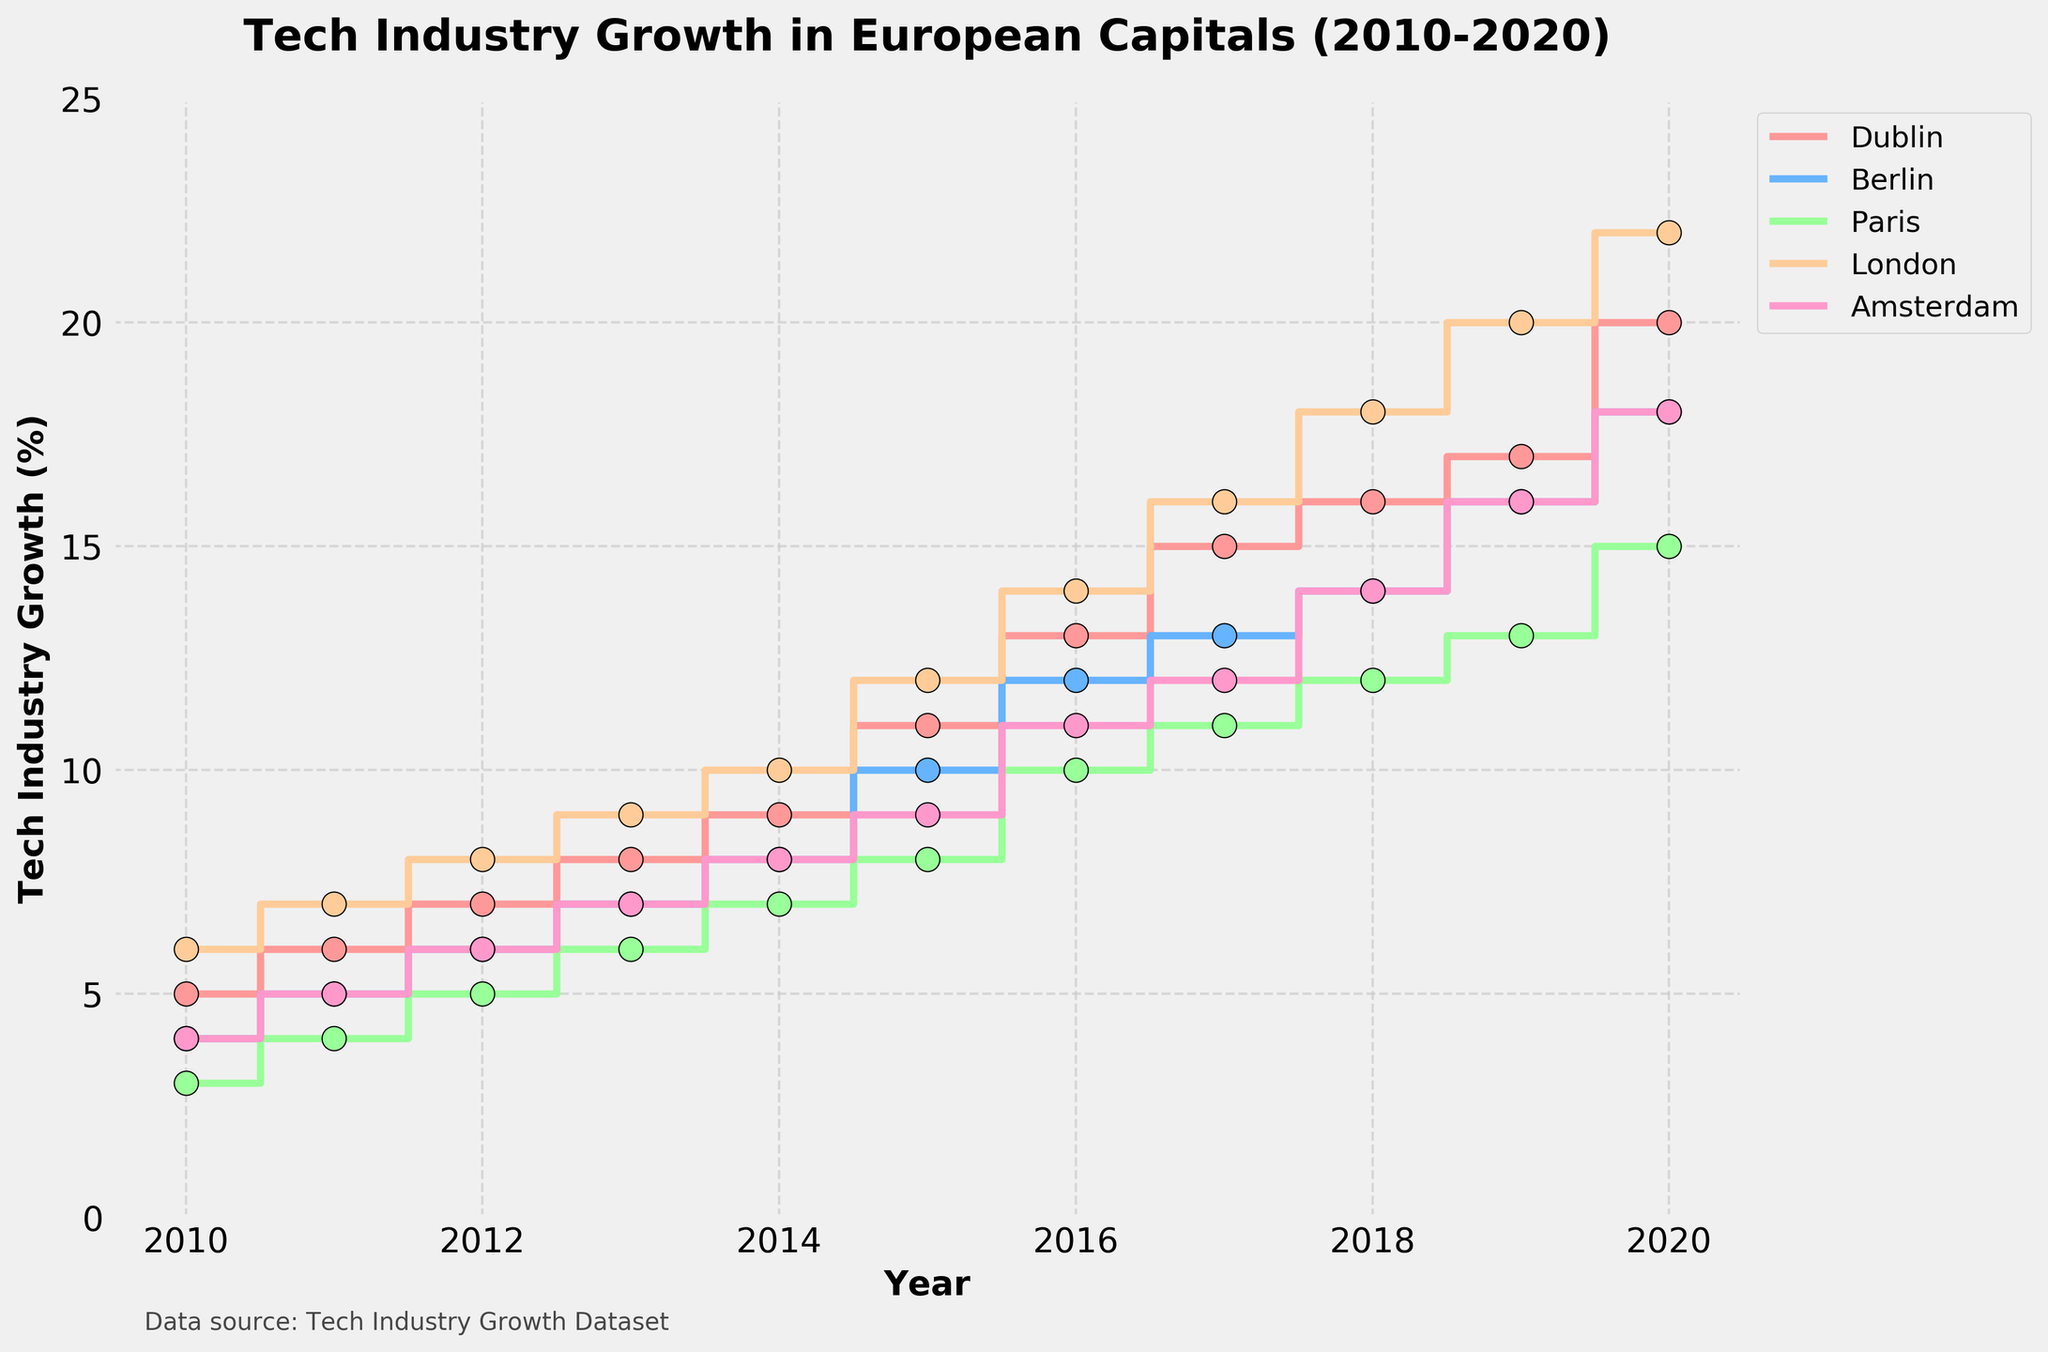What is the title of the plot? The title is located at the top center of the figure and it reads 'Tech Industry Growth in European Capitals (2010-2020)'.
Answer: Tech Industry Growth in European Capitals (2010-2020) Which city had the highest tech industry growth percentage in 2020? By looking at the endpoint of each city's step line, London is at the highest point in 2020 with a tech industry growth percentage of 22%.
Answer: London How did Dublin's tech industry growth percentage change between 2016 and 2017? The figure shows that Dublin's tech industry growth percentage increased from 13% in 2016 to 15% in 2017, which is a 2% increase.
Answer: 2% Which two cities had an equal tech industry growth percentage in 2018? The step lines and scatter points indicate that Berlin and Amsterdam both had a tech industry growth percentage of 14% in 2018.
Answer: Berlin and Amsterdam Compare the tech industry growth percentage between Paris and Dublin in 2015. From the plot, Dublin's tech industry growth percentage in 2015 is 11%, while Paris stands at 8%. Therefore, Dublin had a 3% higher growth percentage than Paris in 2015.
Answer: Dublin has a 3% higher growth percentage What is the trend of Dublin's tech industry growth percentage over the 10 years? The step line for Dublin shows a consistent upward trend from 5% in 2010 to 20% in 2020, indicating steady growth over the decade.
Answer: Steady upward trend Between which years did London see the largest increase in tech industry growth percentage? The step rise for London is steepest between 2017 and 2018, where it increased from 16% to 18%, a 2% rise. Therefore, London saw the largest increase during these years.
Answer: 2017 to 2018 In which year did the tech industry growth in Amsterdam equal that of Berlin? The plot shows that the tech industry growth percentages of Amsterdam and Berlin were both 16% in 2019.
Answer: 2019 How does the tech industry growth in Paris in 2013 compare to that in Berlin in the same year? In 2013, Paris had a tech industry growth of 6%, while Berlin had a growth of 7%. Thus, Berlin's growth was 1% higher than Paris's.
Answer: Berlin's was 1% higher Which city experienced the smoothest growth in tech industry percentage? By evaluating the step lines, Paris had the smoothest growth with no dramatic rises or drops, showing a consistent increase each year.
Answer: Paris 